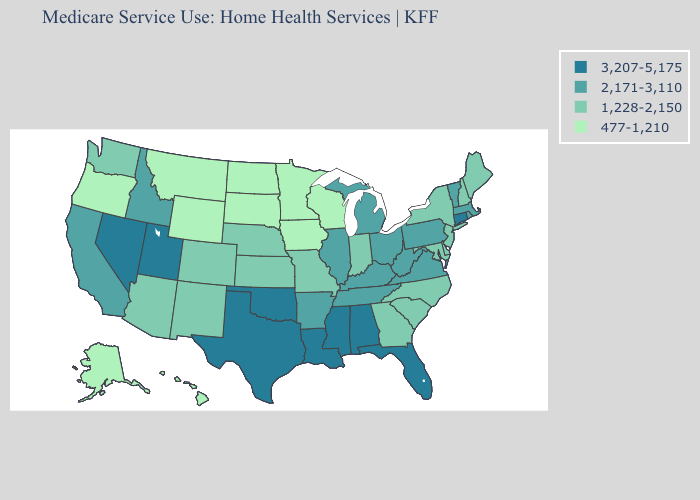Does the map have missing data?
Keep it brief. No. What is the highest value in the South ?
Short answer required. 3,207-5,175. Does Wisconsin have a lower value than Alaska?
Keep it brief. No. What is the value of Pennsylvania?
Give a very brief answer. 2,171-3,110. What is the value of Kentucky?
Answer briefly. 2,171-3,110. Is the legend a continuous bar?
Keep it brief. No. Does Wyoming have the highest value in the West?
Short answer required. No. Does Kentucky have the highest value in the South?
Concise answer only. No. What is the lowest value in states that border Texas?
Short answer required. 1,228-2,150. What is the value of Wisconsin?
Keep it brief. 477-1,210. Among the states that border Tennessee , which have the lowest value?
Concise answer only. Georgia, Missouri, North Carolina. What is the lowest value in the West?
Keep it brief. 477-1,210. Is the legend a continuous bar?
Concise answer only. No. What is the lowest value in the USA?
Answer briefly. 477-1,210. 